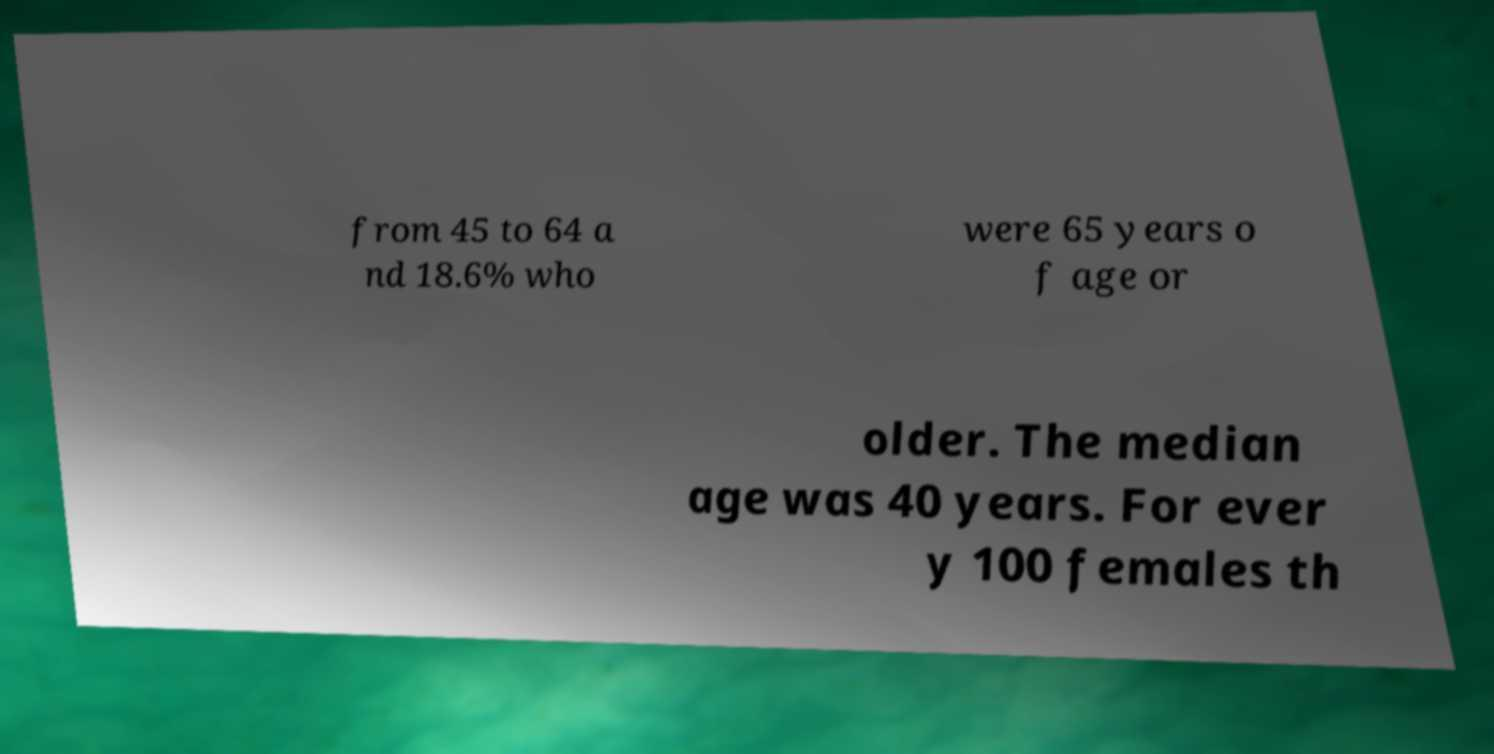Can you read and provide the text displayed in the image?This photo seems to have some interesting text. Can you extract and type it out for me? from 45 to 64 a nd 18.6% who were 65 years o f age or older. The median age was 40 years. For ever y 100 females th 